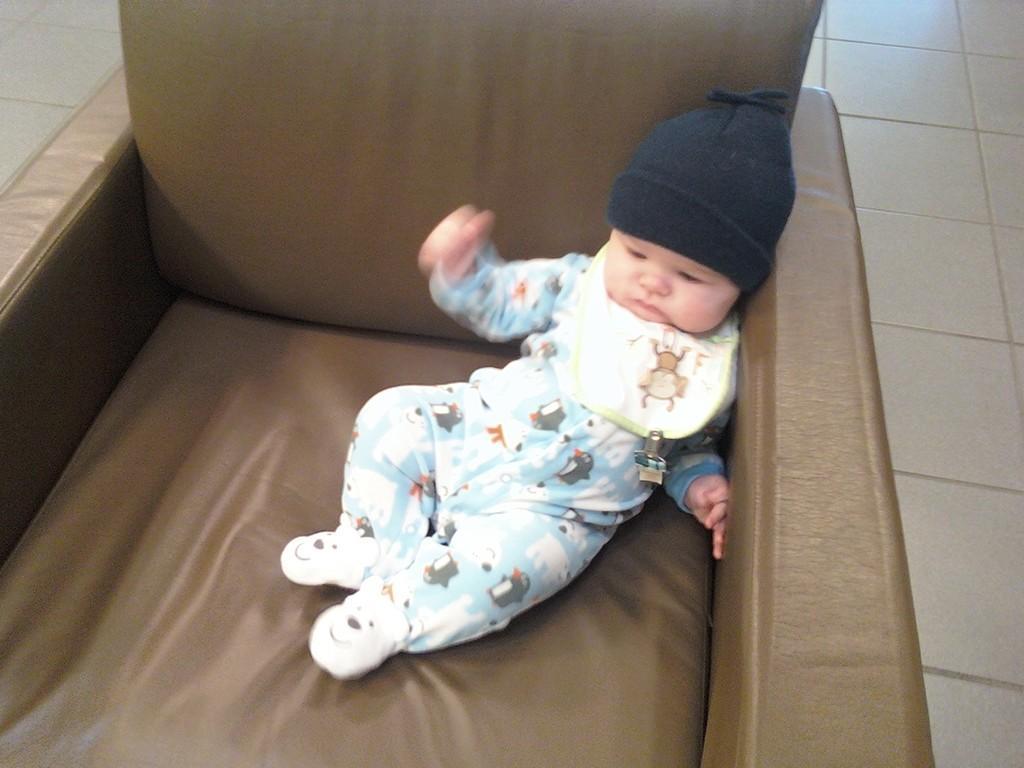Please provide a concise description of this image. In this image we can see a baby sitting on the couch. In the background there is a floor. 